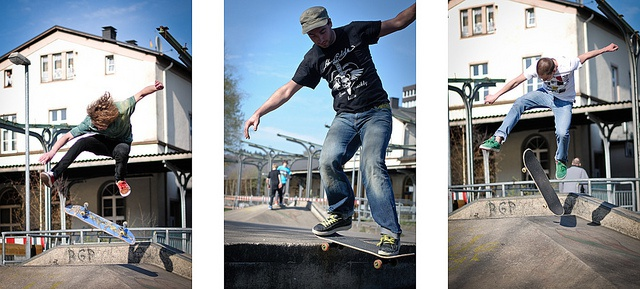Describe the objects in this image and their specific colors. I can see people in gray, black, darkgray, and blue tones, people in gray, white, black, and darkgray tones, people in gray, black, lightgray, and darkgray tones, skateboard in gray and black tones, and skateboard in gray, black, ivory, and darkgray tones in this image. 